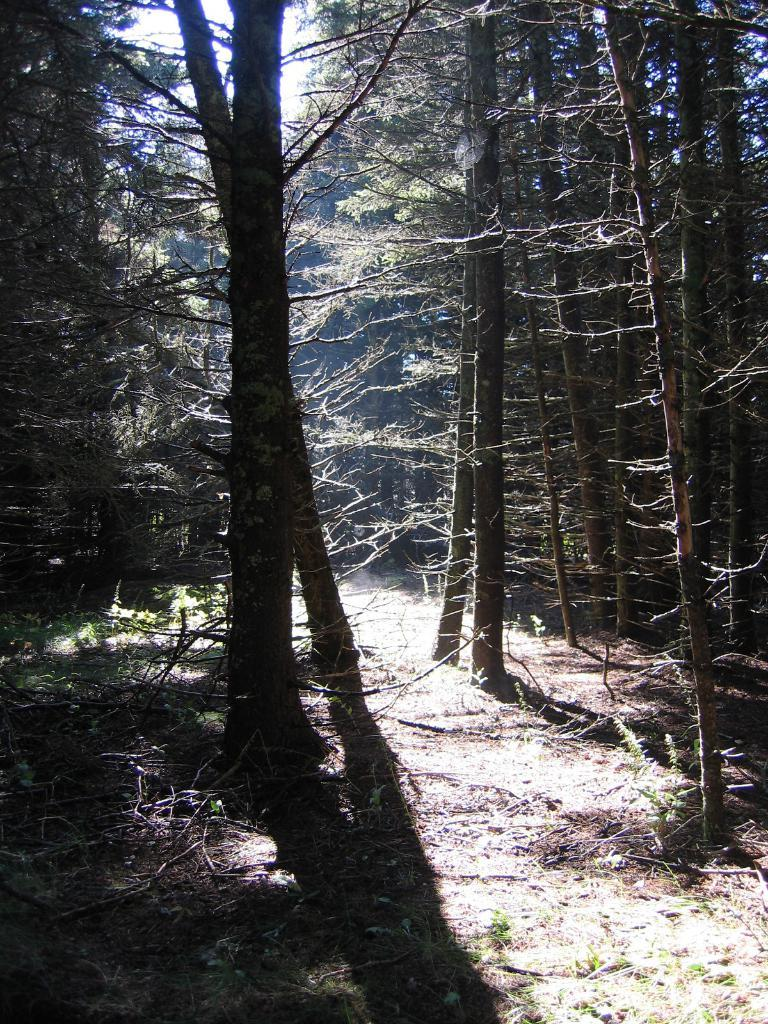What type of vegetation can be seen in the image? There are trees in the image. What else can be seen on the ground in the image? There are branches on the path in the image. What is visible in the background of the image? The sky is visible behind the trees in the image. Can you see any jelly on the branches in the image? There is no jelly present on the branches in the image. 